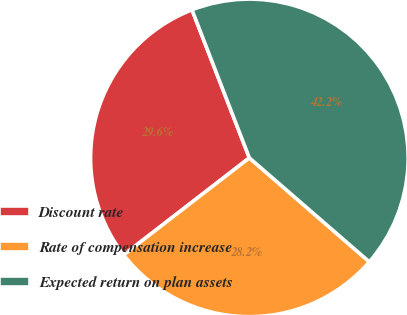Convert chart. <chart><loc_0><loc_0><loc_500><loc_500><pie_chart><fcel>Discount rate<fcel>Rate of compensation increase<fcel>Expected return on plan assets<nl><fcel>29.58%<fcel>28.17%<fcel>42.25%<nl></chart> 